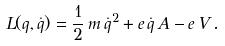<formula> <loc_0><loc_0><loc_500><loc_500>L ( q , \dot { q } ) = \frac { 1 } { 2 } \, m \, \dot { q } ^ { 2 } + e \, \dot { q } \, A - e \, V \, .</formula> 